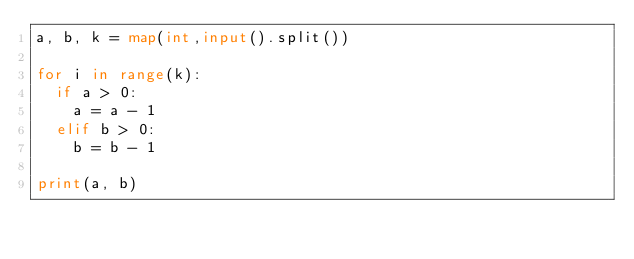Convert code to text. <code><loc_0><loc_0><loc_500><loc_500><_Python_>a, b, k = map(int,input().split())

for i in range(k):
  if a > 0:
    a = a - 1
  elif b > 0:
    b = b - 1

print(a, b)</code> 